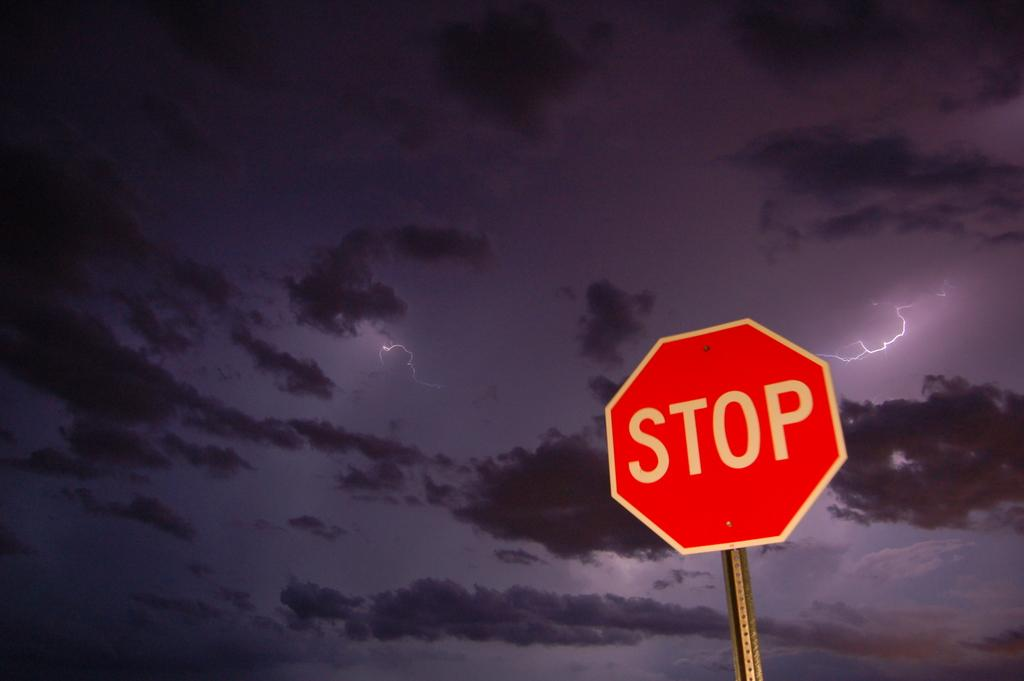<image>
Write a terse but informative summary of the picture. Octagon sign with white letters spelling STOP in the storm of the night. 